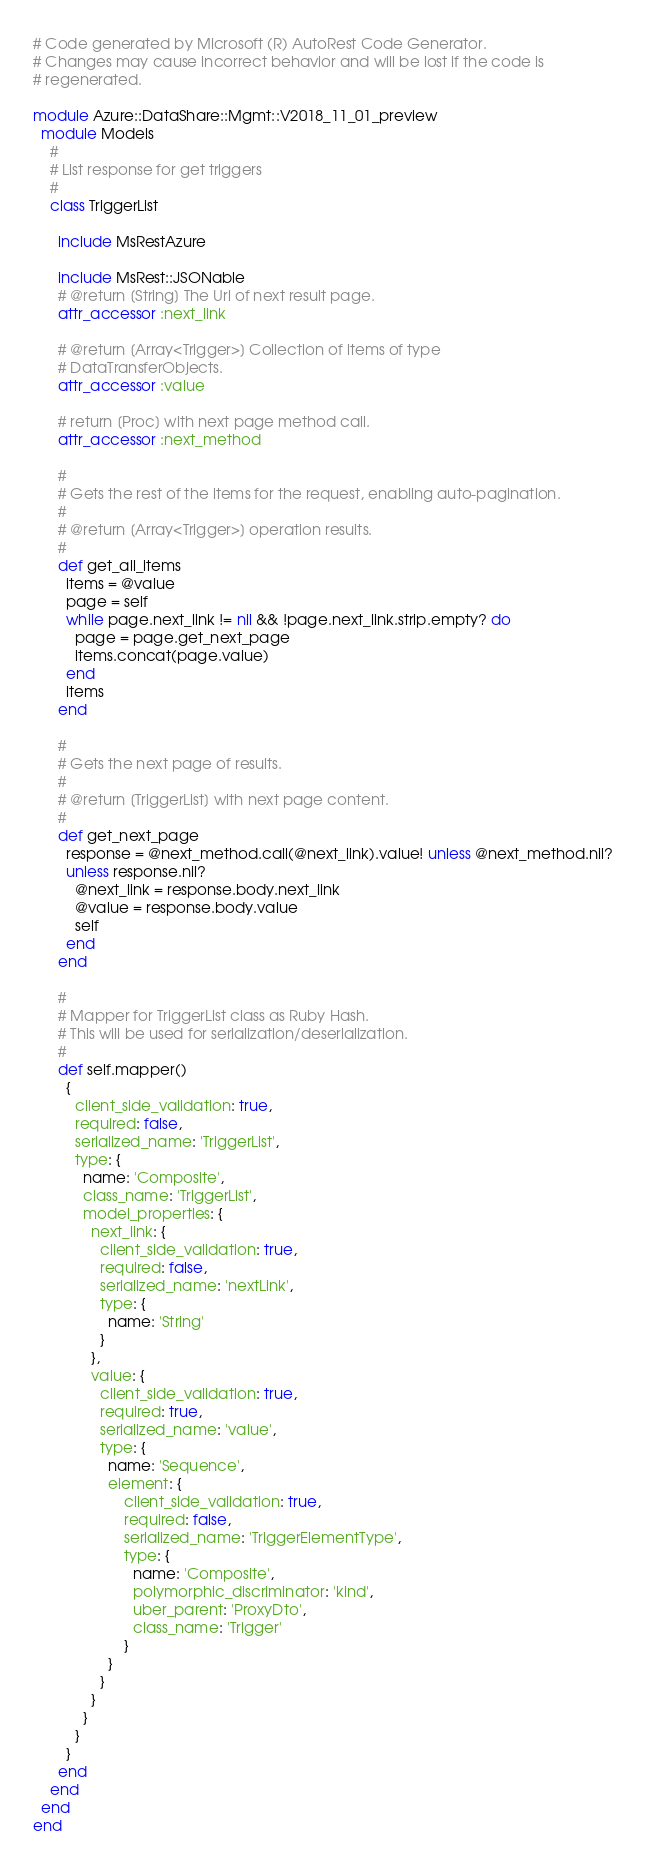Convert code to text. <code><loc_0><loc_0><loc_500><loc_500><_Ruby_># Code generated by Microsoft (R) AutoRest Code Generator.
# Changes may cause incorrect behavior and will be lost if the code is
# regenerated.

module Azure::DataShare::Mgmt::V2018_11_01_preview
  module Models
    #
    # List response for get triggers
    #
    class TriggerList

      include MsRestAzure

      include MsRest::JSONable
      # @return [String] The Url of next result page.
      attr_accessor :next_link

      # @return [Array<Trigger>] Collection of items of type
      # DataTransferObjects.
      attr_accessor :value

      # return [Proc] with next page method call.
      attr_accessor :next_method

      #
      # Gets the rest of the items for the request, enabling auto-pagination.
      #
      # @return [Array<Trigger>] operation results.
      #
      def get_all_items
        items = @value
        page = self
        while page.next_link != nil && !page.next_link.strip.empty? do
          page = page.get_next_page
          items.concat(page.value)
        end
        items
      end

      #
      # Gets the next page of results.
      #
      # @return [TriggerList] with next page content.
      #
      def get_next_page
        response = @next_method.call(@next_link).value! unless @next_method.nil?
        unless response.nil?
          @next_link = response.body.next_link
          @value = response.body.value
          self
        end
      end

      #
      # Mapper for TriggerList class as Ruby Hash.
      # This will be used for serialization/deserialization.
      #
      def self.mapper()
        {
          client_side_validation: true,
          required: false,
          serialized_name: 'TriggerList',
          type: {
            name: 'Composite',
            class_name: 'TriggerList',
            model_properties: {
              next_link: {
                client_side_validation: true,
                required: false,
                serialized_name: 'nextLink',
                type: {
                  name: 'String'
                }
              },
              value: {
                client_side_validation: true,
                required: true,
                serialized_name: 'value',
                type: {
                  name: 'Sequence',
                  element: {
                      client_side_validation: true,
                      required: false,
                      serialized_name: 'TriggerElementType',
                      type: {
                        name: 'Composite',
                        polymorphic_discriminator: 'kind',
                        uber_parent: 'ProxyDto',
                        class_name: 'Trigger'
                      }
                  }
                }
              }
            }
          }
        }
      end
    end
  end
end
</code> 